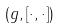Convert formula to latex. <formula><loc_0><loc_0><loc_500><loc_500>( g , [ \cdot , \cdot ] )</formula> 